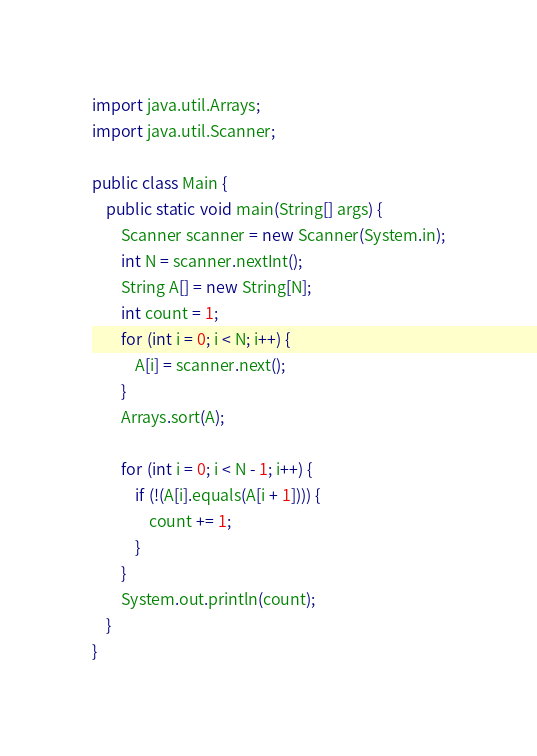Convert code to text. <code><loc_0><loc_0><loc_500><loc_500><_Java_>import java.util.Arrays;
import java.util.Scanner;

public class Main {
	public static void main(String[] args) {
		Scanner scanner = new Scanner(System.in);
		int N = scanner.nextInt();
		String A[] = new String[N];
		int count = 1;
		for (int i = 0; i < N; i++) {
			A[i] = scanner.next();
		}
		Arrays.sort(A);

		for (int i = 0; i < N - 1; i++) {
			if (!(A[i].equals(A[i + 1]))) {
				count += 1;
			}
		}
		System.out.println(count);
	}
}
</code> 